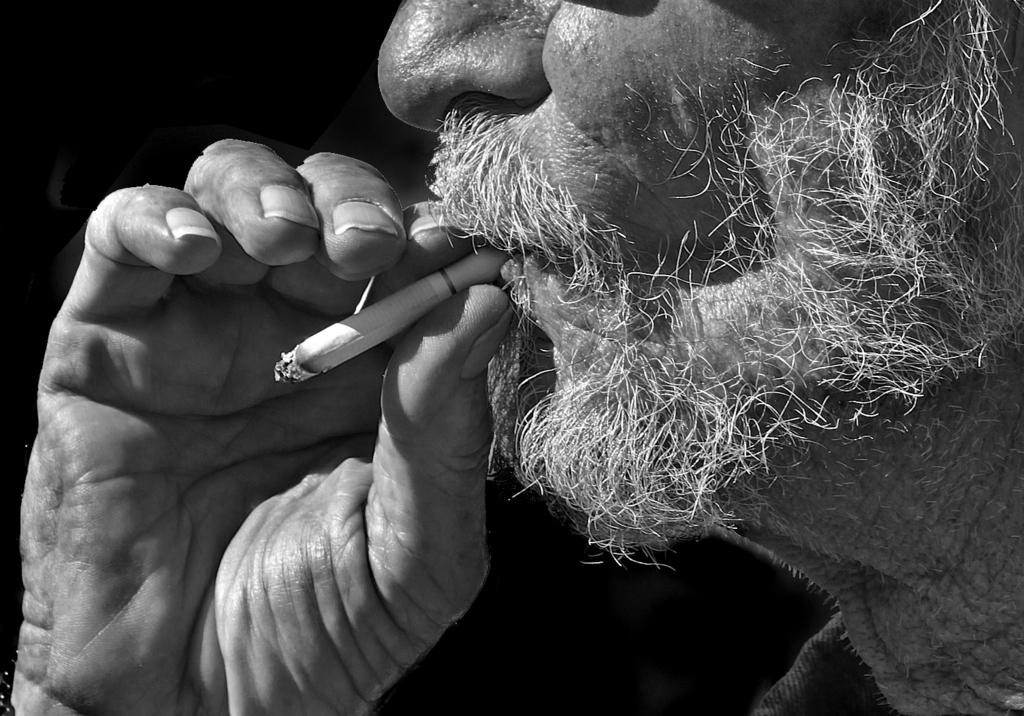What is the main subject of the image? There is a person in the image. What is the person holding in the image? The person is holding a cigarette. What color is the background of the image? The background of the image is black. What type of cabbage is being discussed by the secretary in the committee meeting in the image? There is no secretary or committee meeting present in the image. The image only features a person holding a cigarette against a black background. 